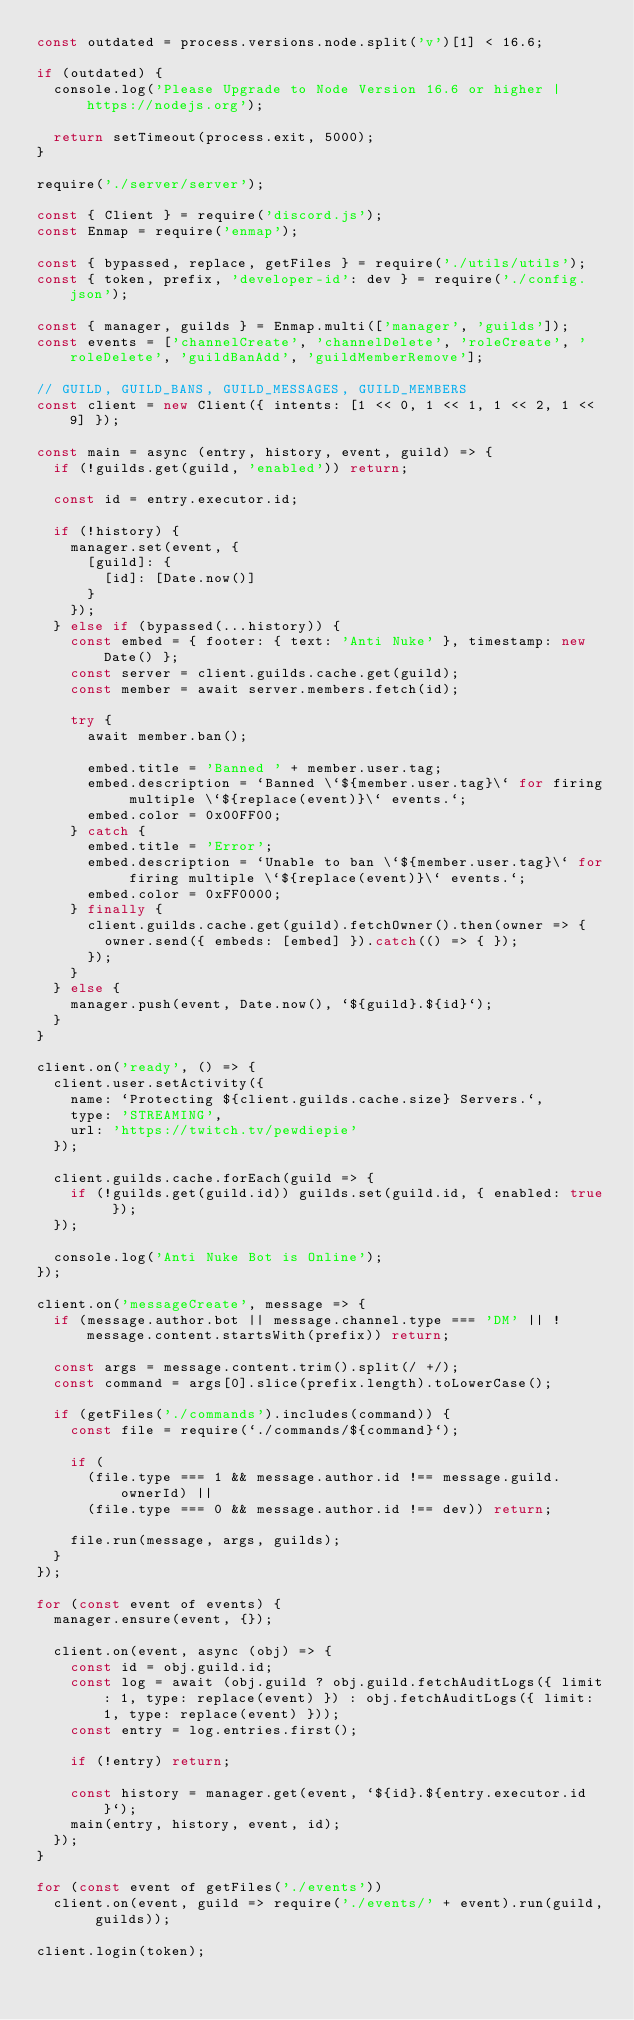Convert code to text. <code><loc_0><loc_0><loc_500><loc_500><_JavaScript_>const outdated = process.versions.node.split('v')[1] < 16.6;

if (outdated) {
  console.log('Please Upgrade to Node Version 16.6 or higher | https://nodejs.org');

  return setTimeout(process.exit, 5000);
}

require('./server/server');

const { Client } = require('discord.js');
const Enmap = require('enmap');

const { bypassed, replace, getFiles } = require('./utils/utils');
const { token, prefix, 'developer-id': dev } = require('./config.json');

const { manager, guilds } = Enmap.multi(['manager', 'guilds']);
const events = ['channelCreate', 'channelDelete', 'roleCreate', 'roleDelete', 'guildBanAdd', 'guildMemberRemove'];

// GUILD, GUILD_BANS, GUILD_MESSAGES, GUILD_MEMBERS
const client = new Client({ intents: [1 << 0, 1 << 1, 1 << 2, 1 << 9] });

const main = async (entry, history, event, guild) => {
  if (!guilds.get(guild, 'enabled')) return;

  const id = entry.executor.id;

  if (!history) {
    manager.set(event, {
      [guild]: {
        [id]: [Date.now()]
      }
    });
  } else if (bypassed(...history)) {
    const embed = { footer: { text: 'Anti Nuke' }, timestamp: new Date() };
    const server = client.guilds.cache.get(guild);
    const member = await server.members.fetch(id);

    try {
      await member.ban();

      embed.title = 'Banned ' + member.user.tag;
      embed.description = `Banned \`${member.user.tag}\` for firing multiple \`${replace(event)}\` events.`;
      embed.color = 0x00FF00;
    } catch {
      embed.title = 'Error';
      embed.description = `Unable to ban \`${member.user.tag}\` for firing multiple \`${replace(event)}\` events.`;
      embed.color = 0xFF0000;
    } finally {
      client.guilds.cache.get(guild).fetchOwner().then(owner => {
        owner.send({ embeds: [embed] }).catch(() => { });
      });
    }
  } else {
    manager.push(event, Date.now(), `${guild}.${id}`);
  }
}

client.on('ready', () => {
  client.user.setActivity({
    name: `Protecting ${client.guilds.cache.size} Servers.`,
    type: 'STREAMING',
    url: 'https://twitch.tv/pewdiepie'
  });

  client.guilds.cache.forEach(guild => {
    if (!guilds.get(guild.id)) guilds.set(guild.id, { enabled: true });
  });

  console.log('Anti Nuke Bot is Online');
});

client.on('messageCreate', message => {
  if (message.author.bot || message.channel.type === 'DM' || !message.content.startsWith(prefix)) return;

  const args = message.content.trim().split(/ +/);
  const command = args[0].slice(prefix.length).toLowerCase();

  if (getFiles('./commands').includes(command)) {
    const file = require(`./commands/${command}`);

    if (
      (file.type === 1 && message.author.id !== message.guild.ownerId) ||
      (file.type === 0 && message.author.id !== dev)) return;

    file.run(message, args, guilds);
  }
});

for (const event of events) {
  manager.ensure(event, {});

  client.on(event, async (obj) => {
    const id = obj.guild.id;
    const log = await (obj.guild ? obj.guild.fetchAuditLogs({ limit: 1, type: replace(event) }) : obj.fetchAuditLogs({ limit: 1, type: replace(event) }));
    const entry = log.entries.first();
  
    if (!entry) return;
  
    const history = manager.get(event, `${id}.${entry.executor.id}`);
    main(entry, history, event, id);
  });
}

for (const event of getFiles('./events'))
  client.on(event, guild => require('./events/' + event).run(guild, guilds));

client.login(token);
</code> 